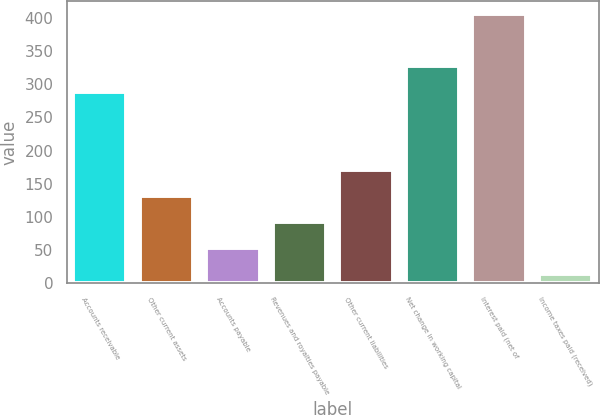Convert chart to OTSL. <chart><loc_0><loc_0><loc_500><loc_500><bar_chart><fcel>Accounts receivable<fcel>Other current assets<fcel>Accounts payable<fcel>Revenues and royalties payable<fcel>Other current liabilities<fcel>Net change in working capital<fcel>Interest paid (net of<fcel>Income taxes paid (received)<nl><fcel>288<fcel>130.9<fcel>52.3<fcel>91.6<fcel>170.2<fcel>327.3<fcel>406<fcel>13<nl></chart> 